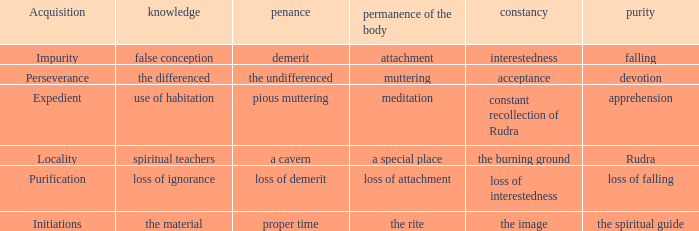 what's the permanence of the body where constancy is interestedness Attachment. 